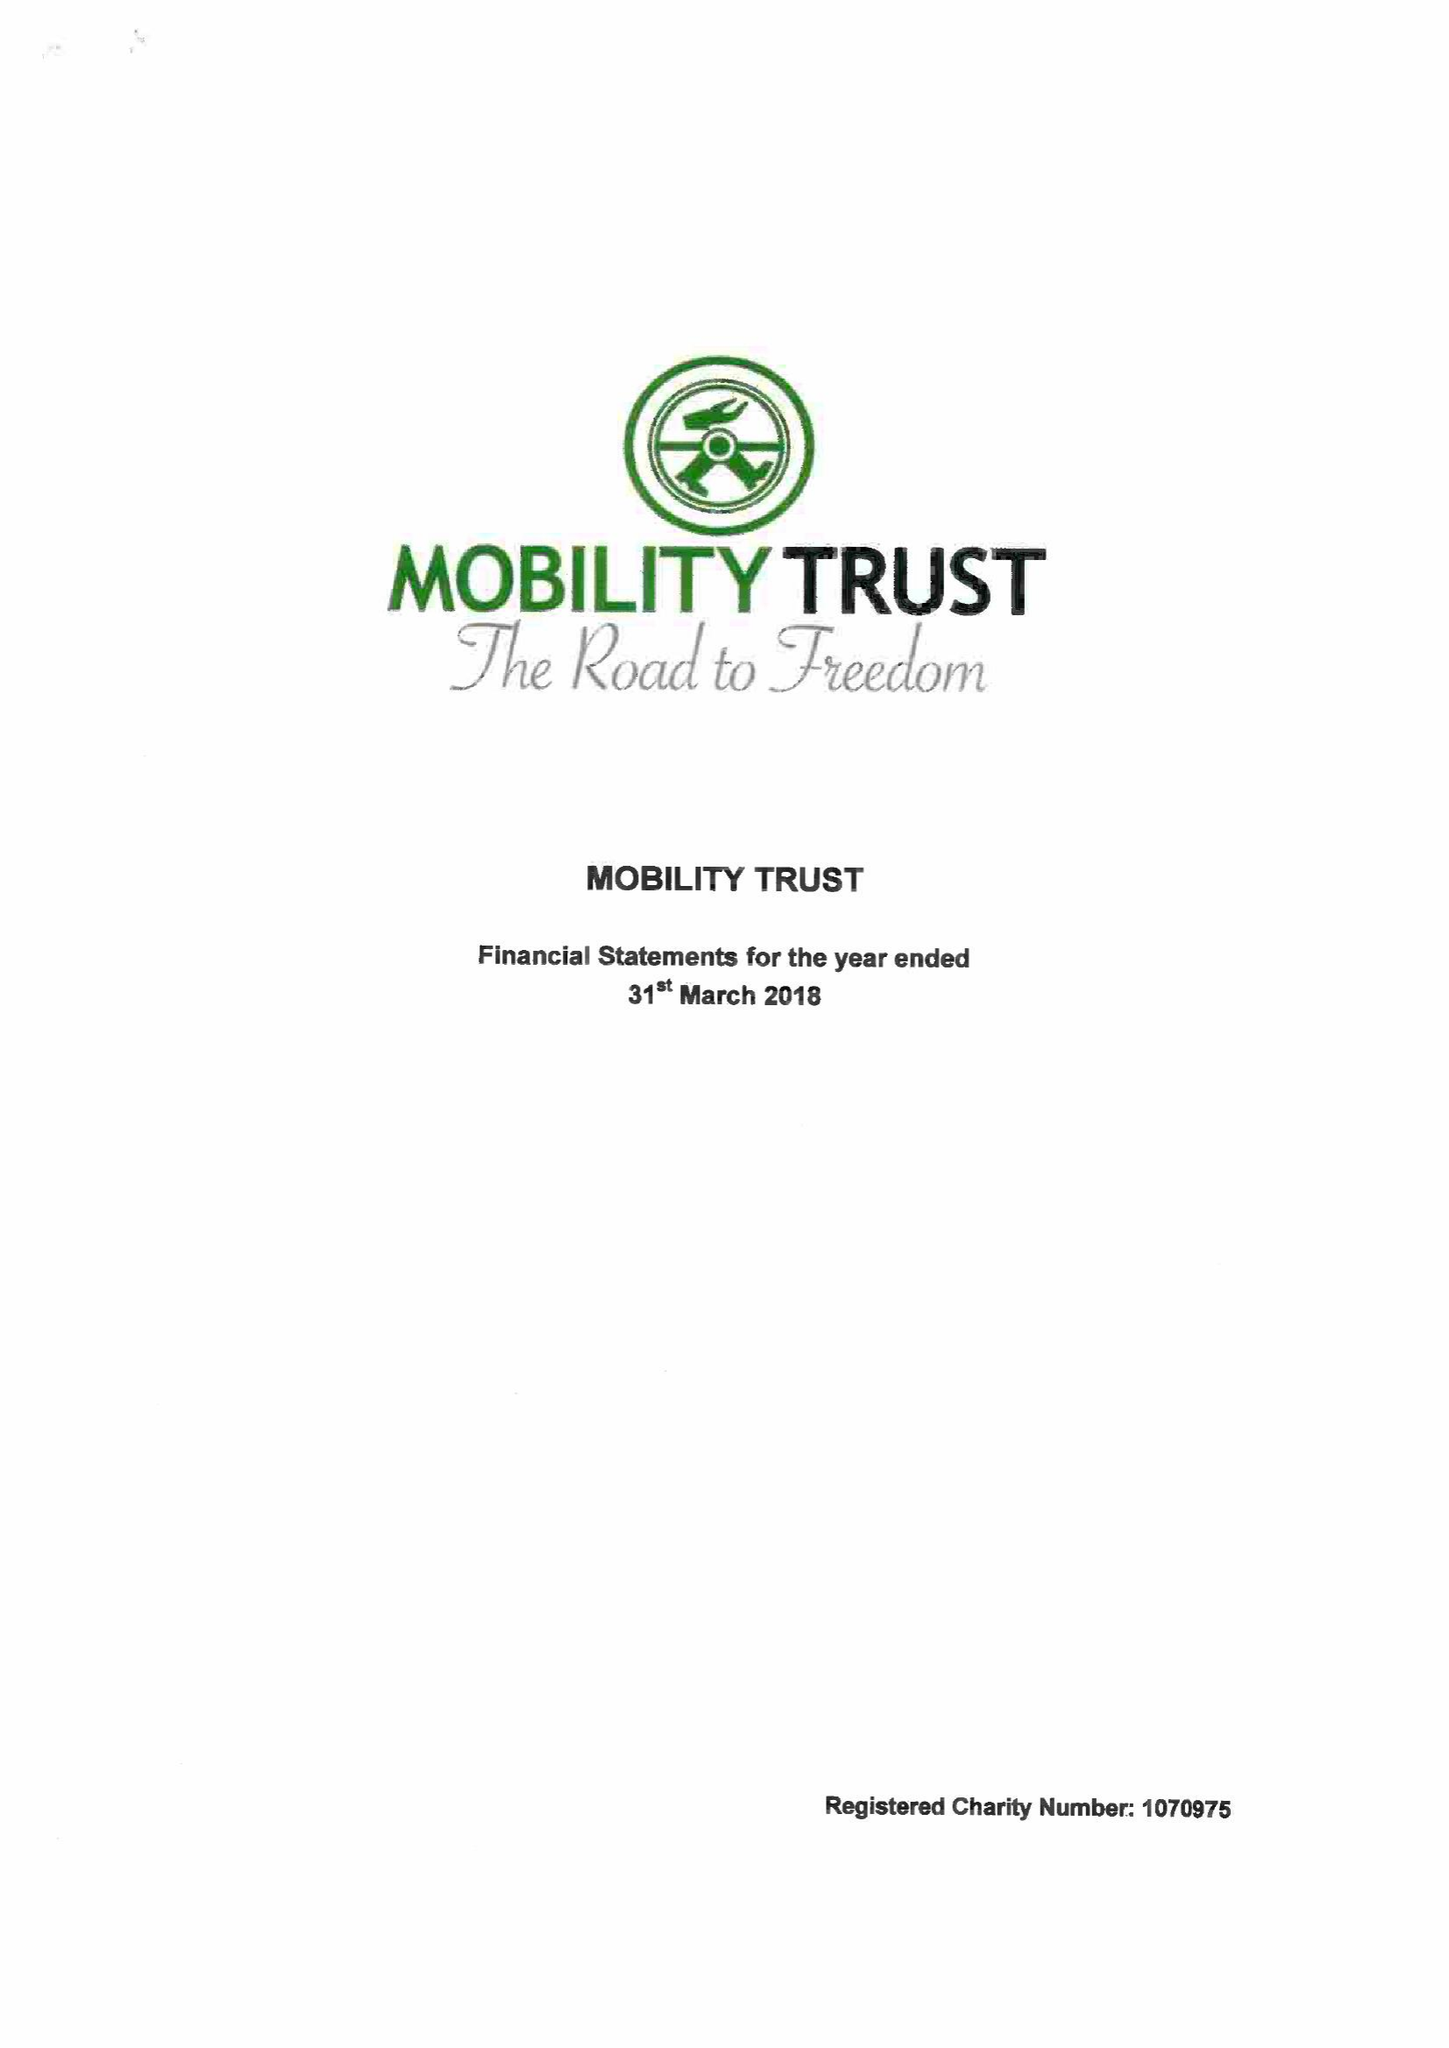What is the value for the charity_number?
Answer the question using a single word or phrase. 1070975 